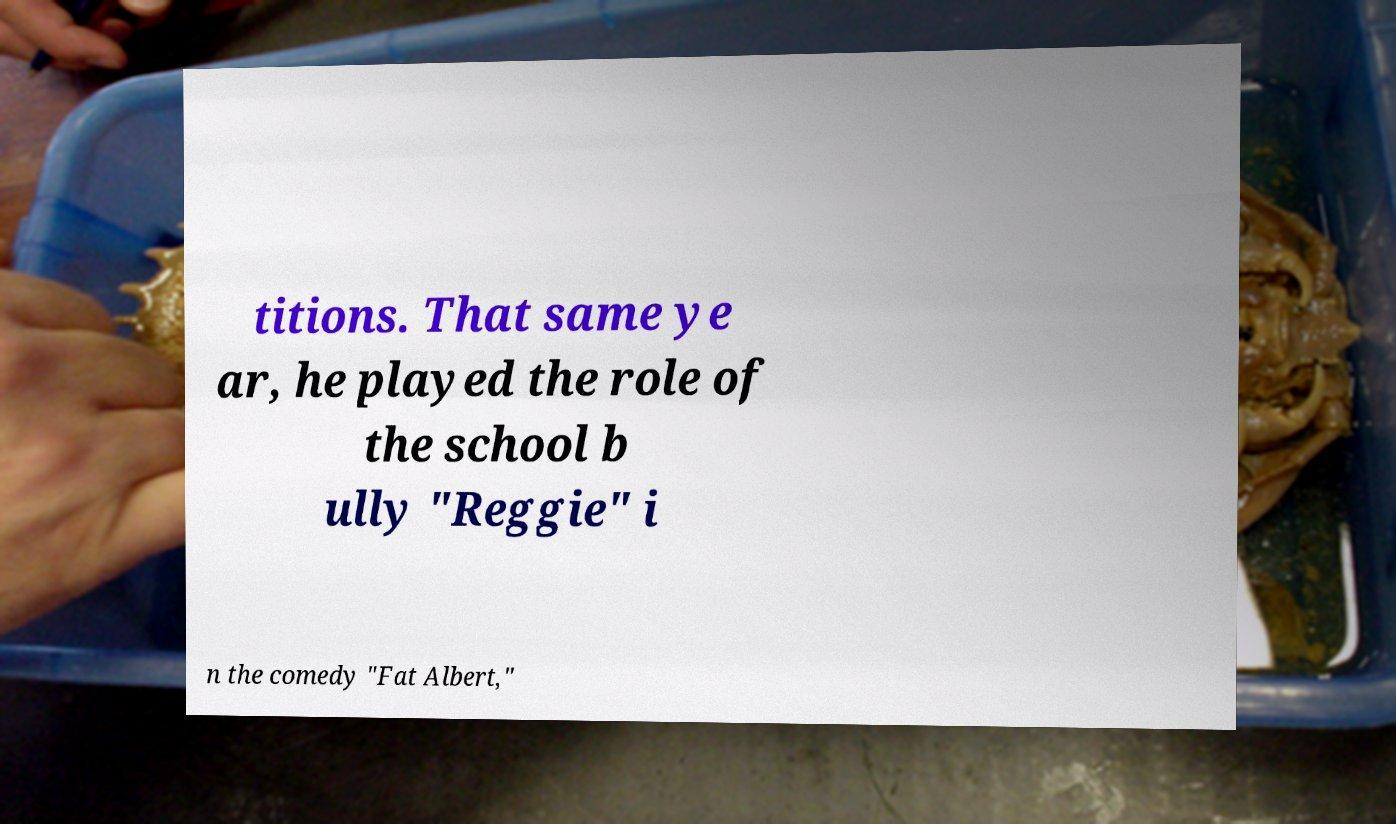Please read and relay the text visible in this image. What does it say? titions. That same ye ar, he played the role of the school b ully "Reggie" i n the comedy "Fat Albert," 